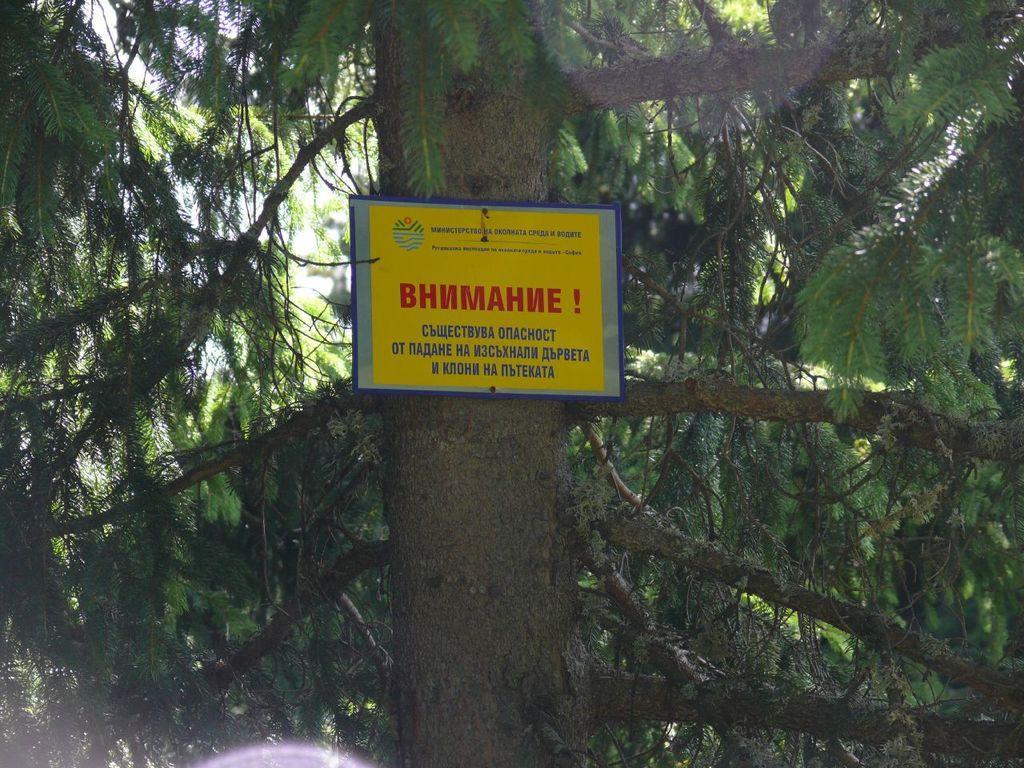Can you describe this image briefly? In this image I can see a tree which is green and brown in color and to the tree I can see a board which is yellow, blue and red in color. In the background I can see the sky. 